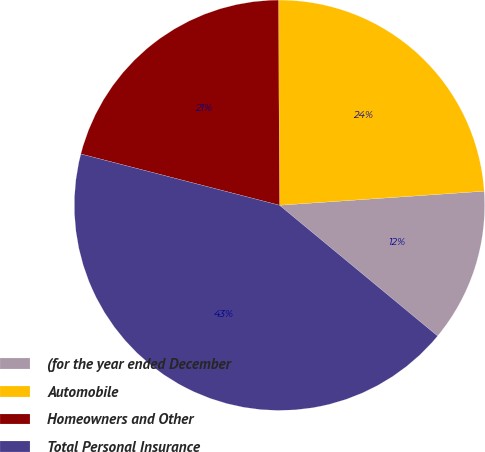<chart> <loc_0><loc_0><loc_500><loc_500><pie_chart><fcel>(for the year ended December<fcel>Automobile<fcel>Homeowners and Other<fcel>Total Personal Insurance<nl><fcel>12.09%<fcel>23.99%<fcel>20.9%<fcel>43.02%<nl></chart> 